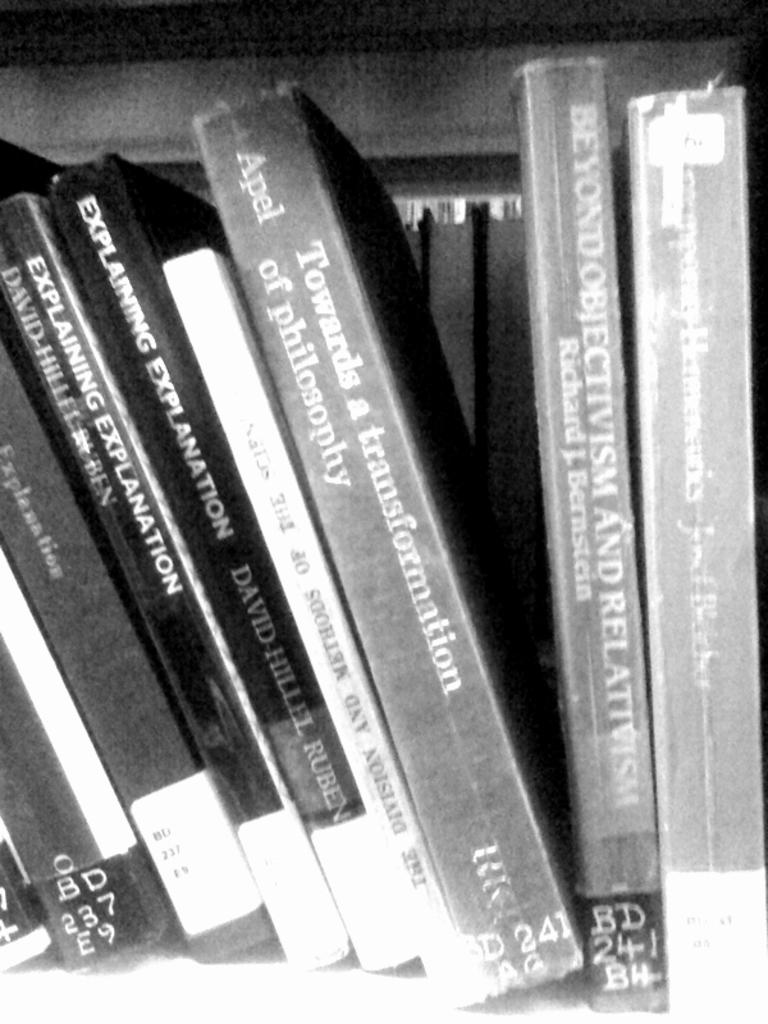<image>
Write a terse but informative summary of the picture. Books are lined up together with several titled Explaining Explanation. 